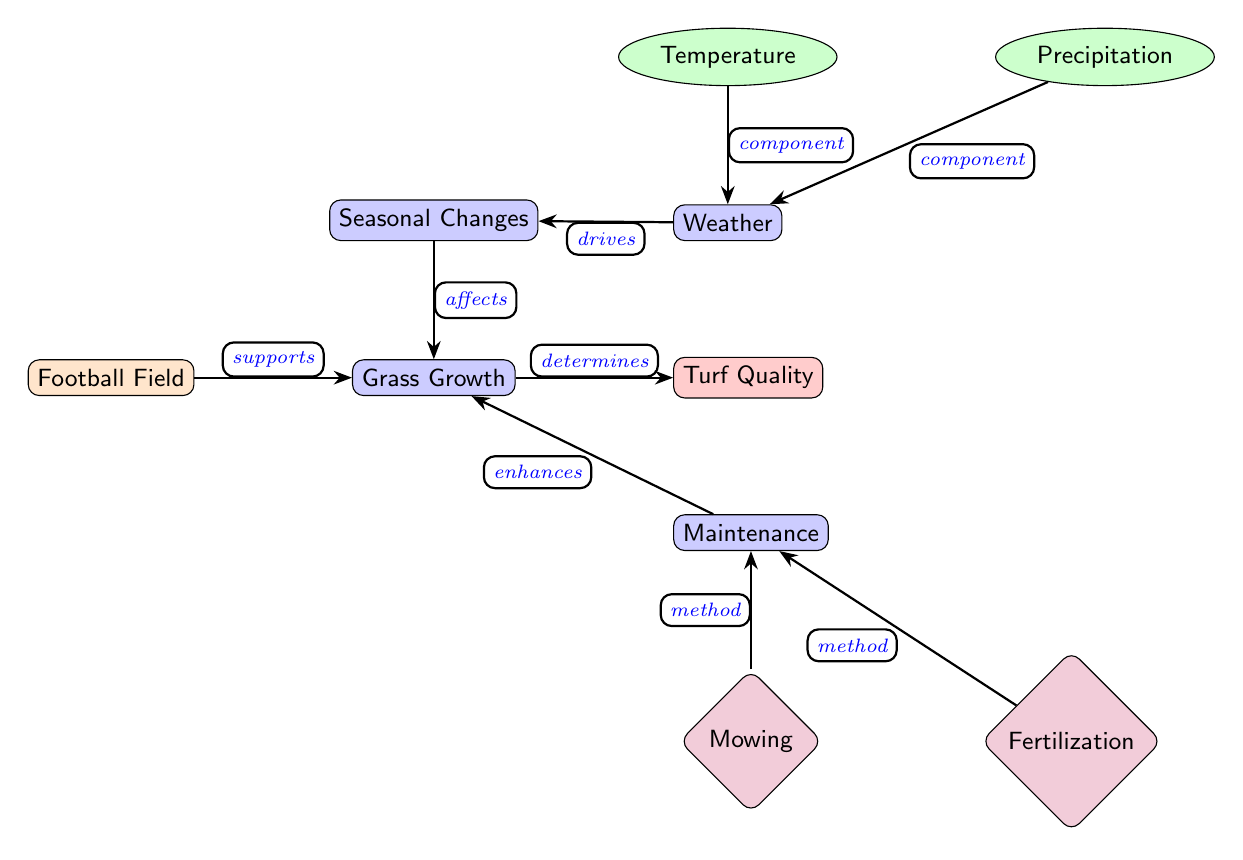What is the main focus of the diagram? The main focus of the diagram is the relationship between weather, maintenance, and grass growth on a football field. The central node labeled "Football Field" connects various factors and methods that influence grass growth and quality.
Answer: Football Field How many components are shown in the weather section? In the weather section, there are two components: "Temperature" and "Precipitation". Each of these components is connected to the "Weather" node, indicating they are part of this section.
Answer: 2 What enhances grass growth according to the diagram? The diagram indicates that "Maintenance" enhances grass growth. The relationship is shown with an edge labeled "enhances" connecting "Maintenance" to "Grass Growth".
Answer: Maintenance What is affected by seasonal changes? Seasonal changes affect "Grass Growth" as indicated by the edge labeled "affects" linking "Seasonal Changes" to "Grass Growth". This highlights the impact of different seasons on the growth rate of grass on the football field.
Answer: Grass Growth What drives seasonal changes? According to the diagram, "Weather" drives seasonal changes. The relationship is illustrated with an edge labeled "drives" that connects "Weather" to "Seasonal Changes".
Answer: Weather Which two maintenance methods are identified in the diagram? The diagram identifies two maintenance methods: "Mowing" and "Fertilization". These methods are represented as nodes linked to "Maintenance", demonstrating their role in maintaining turf quality.
Answer: Mowing, Fertilization How does grass growth determine turf quality? The diagram depicts that "Grass Growth" determines "Turf Quality" through an edge labeled "determines". This indicates that the quality of the turf is reliant on the health and growth of the grass.
Answer: Turf Quality What is the effect of temperature on growth? The diagram implies that "Temperature" is a component of "Weather", which in turn drives "Seasonal Changes" that affect "Grass Growth". Thus, Temperature indirectly impacts grass growth through its effects on seasonal patterns.
Answer: Indirect effect What overall outcome is influenced by grass growth? The overall outcome influenced by grass growth, as shown in the diagram, is "Turf Quality". The diagram explicitly connects these two nodes, indicating a direct relationship where the quality of turf is contingent upon the growth of grass.
Answer: Turf Quality 